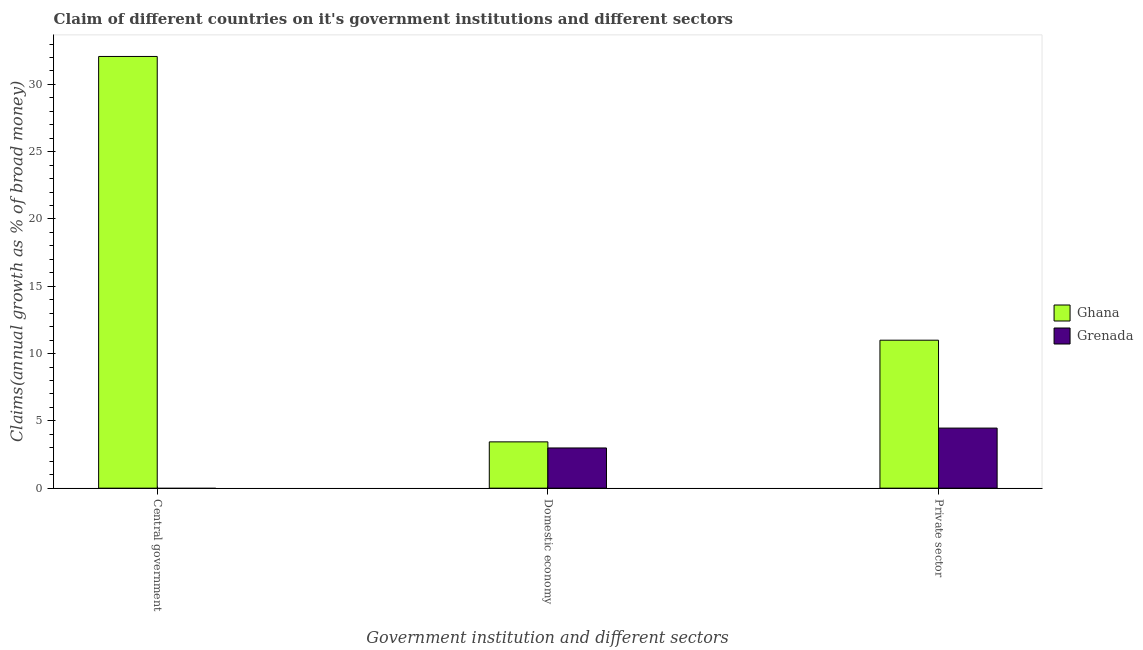How many different coloured bars are there?
Make the answer very short. 2. What is the label of the 3rd group of bars from the left?
Keep it short and to the point. Private sector. What is the percentage of claim on the domestic economy in Grenada?
Provide a succinct answer. 2.99. Across all countries, what is the maximum percentage of claim on the central government?
Your answer should be very brief. 32.08. What is the total percentage of claim on the private sector in the graph?
Keep it short and to the point. 15.46. What is the difference between the percentage of claim on the domestic economy in Grenada and that in Ghana?
Provide a short and direct response. -0.45. What is the difference between the percentage of claim on the private sector in Grenada and the percentage of claim on the central government in Ghana?
Provide a short and direct response. -27.61. What is the average percentage of claim on the domestic economy per country?
Provide a short and direct response. 3.21. What is the difference between the percentage of claim on the private sector and percentage of claim on the domestic economy in Ghana?
Keep it short and to the point. 7.55. What is the ratio of the percentage of claim on the private sector in Grenada to that in Ghana?
Your answer should be compact. 0.41. Is the percentage of claim on the domestic economy in Grenada less than that in Ghana?
Your answer should be compact. Yes. What is the difference between the highest and the second highest percentage of claim on the private sector?
Ensure brevity in your answer.  6.53. What is the difference between the highest and the lowest percentage of claim on the domestic economy?
Make the answer very short. 0.45. In how many countries, is the percentage of claim on the private sector greater than the average percentage of claim on the private sector taken over all countries?
Offer a very short reply. 1. Are all the bars in the graph horizontal?
Provide a short and direct response. No. Are the values on the major ticks of Y-axis written in scientific E-notation?
Give a very brief answer. No. Does the graph contain any zero values?
Offer a terse response. Yes. Does the graph contain grids?
Your response must be concise. No. How are the legend labels stacked?
Your response must be concise. Vertical. What is the title of the graph?
Your answer should be very brief. Claim of different countries on it's government institutions and different sectors. Does "Senegal" appear as one of the legend labels in the graph?
Offer a very short reply. No. What is the label or title of the X-axis?
Give a very brief answer. Government institution and different sectors. What is the label or title of the Y-axis?
Offer a terse response. Claims(annual growth as % of broad money). What is the Claims(annual growth as % of broad money) in Ghana in Central government?
Give a very brief answer. 32.08. What is the Claims(annual growth as % of broad money) of Ghana in Domestic economy?
Your response must be concise. 3.44. What is the Claims(annual growth as % of broad money) in Grenada in Domestic economy?
Your response must be concise. 2.99. What is the Claims(annual growth as % of broad money) in Ghana in Private sector?
Your answer should be compact. 10.99. What is the Claims(annual growth as % of broad money) in Grenada in Private sector?
Provide a short and direct response. 4.46. Across all Government institution and different sectors, what is the maximum Claims(annual growth as % of broad money) of Ghana?
Give a very brief answer. 32.08. Across all Government institution and different sectors, what is the maximum Claims(annual growth as % of broad money) of Grenada?
Give a very brief answer. 4.46. Across all Government institution and different sectors, what is the minimum Claims(annual growth as % of broad money) in Ghana?
Ensure brevity in your answer.  3.44. Across all Government institution and different sectors, what is the minimum Claims(annual growth as % of broad money) of Grenada?
Offer a very short reply. 0. What is the total Claims(annual growth as % of broad money) in Ghana in the graph?
Make the answer very short. 46.51. What is the total Claims(annual growth as % of broad money) of Grenada in the graph?
Your answer should be compact. 7.45. What is the difference between the Claims(annual growth as % of broad money) in Ghana in Central government and that in Domestic economy?
Provide a succinct answer. 28.64. What is the difference between the Claims(annual growth as % of broad money) in Ghana in Central government and that in Private sector?
Ensure brevity in your answer.  21.08. What is the difference between the Claims(annual growth as % of broad money) of Ghana in Domestic economy and that in Private sector?
Ensure brevity in your answer.  -7.55. What is the difference between the Claims(annual growth as % of broad money) in Grenada in Domestic economy and that in Private sector?
Ensure brevity in your answer.  -1.48. What is the difference between the Claims(annual growth as % of broad money) in Ghana in Central government and the Claims(annual growth as % of broad money) in Grenada in Domestic economy?
Provide a succinct answer. 29.09. What is the difference between the Claims(annual growth as % of broad money) of Ghana in Central government and the Claims(annual growth as % of broad money) of Grenada in Private sector?
Provide a succinct answer. 27.61. What is the difference between the Claims(annual growth as % of broad money) of Ghana in Domestic economy and the Claims(annual growth as % of broad money) of Grenada in Private sector?
Provide a succinct answer. -1.02. What is the average Claims(annual growth as % of broad money) in Ghana per Government institution and different sectors?
Your response must be concise. 15.5. What is the average Claims(annual growth as % of broad money) of Grenada per Government institution and different sectors?
Offer a very short reply. 2.48. What is the difference between the Claims(annual growth as % of broad money) in Ghana and Claims(annual growth as % of broad money) in Grenada in Domestic economy?
Provide a short and direct response. 0.45. What is the difference between the Claims(annual growth as % of broad money) of Ghana and Claims(annual growth as % of broad money) of Grenada in Private sector?
Keep it short and to the point. 6.53. What is the ratio of the Claims(annual growth as % of broad money) of Ghana in Central government to that in Domestic economy?
Your answer should be very brief. 9.33. What is the ratio of the Claims(annual growth as % of broad money) of Ghana in Central government to that in Private sector?
Keep it short and to the point. 2.92. What is the ratio of the Claims(annual growth as % of broad money) of Ghana in Domestic economy to that in Private sector?
Your response must be concise. 0.31. What is the ratio of the Claims(annual growth as % of broad money) in Grenada in Domestic economy to that in Private sector?
Keep it short and to the point. 0.67. What is the difference between the highest and the second highest Claims(annual growth as % of broad money) in Ghana?
Offer a terse response. 21.08. What is the difference between the highest and the lowest Claims(annual growth as % of broad money) of Ghana?
Make the answer very short. 28.64. What is the difference between the highest and the lowest Claims(annual growth as % of broad money) of Grenada?
Your response must be concise. 4.46. 